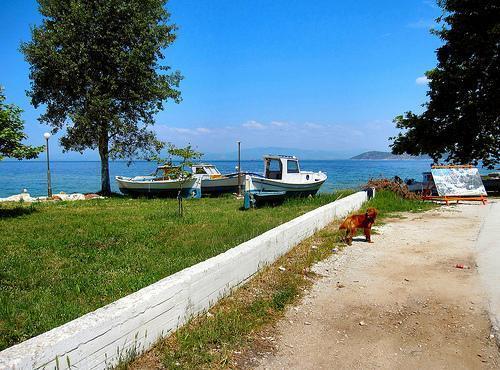How many dogs are in this picture?
Give a very brief answer. 1. How many boats are there?
Give a very brief answer. 2. 